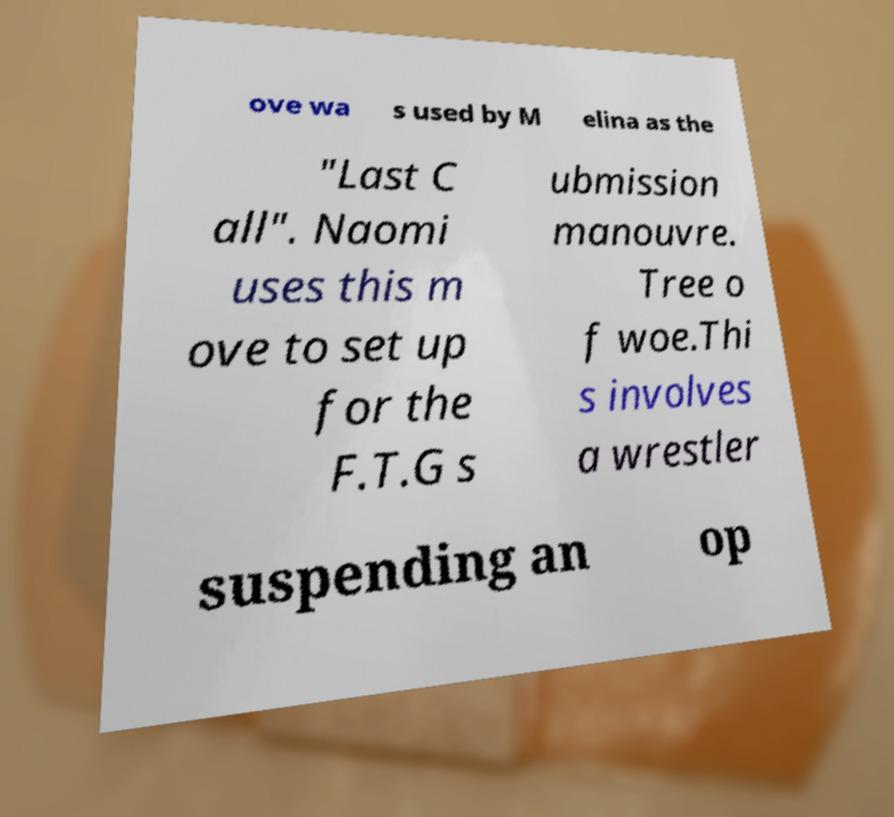Could you extract and type out the text from this image? ove wa s used by M elina as the "Last C all". Naomi uses this m ove to set up for the F.T.G s ubmission manouvre. Tree o f woe.Thi s involves a wrestler suspending an op 